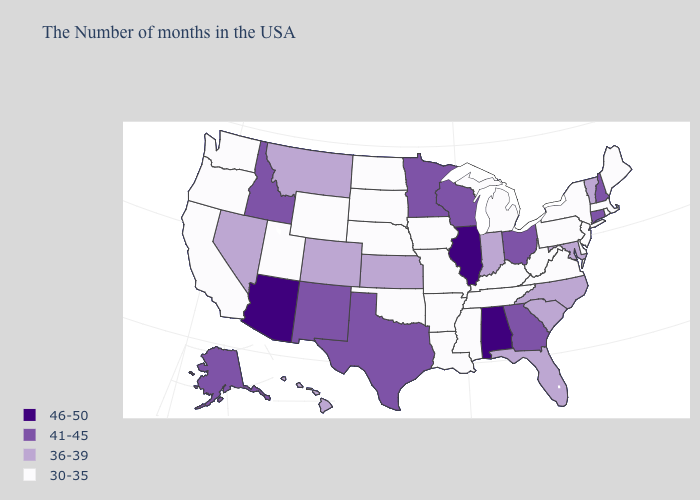How many symbols are there in the legend?
Answer briefly. 4. What is the value of Indiana?
Be succinct. 36-39. Name the states that have a value in the range 46-50?
Answer briefly. Alabama, Illinois, Arizona. Does Alabama have the highest value in the USA?
Concise answer only. Yes. What is the value of Missouri?
Give a very brief answer. 30-35. What is the value of Kentucky?
Answer briefly. 30-35. Name the states that have a value in the range 41-45?
Concise answer only. New Hampshire, Connecticut, Ohio, Georgia, Wisconsin, Minnesota, Texas, New Mexico, Idaho, Alaska. Name the states that have a value in the range 41-45?
Give a very brief answer. New Hampshire, Connecticut, Ohio, Georgia, Wisconsin, Minnesota, Texas, New Mexico, Idaho, Alaska. What is the value of Pennsylvania?
Keep it brief. 30-35. Which states have the lowest value in the USA?
Short answer required. Maine, Massachusetts, Rhode Island, New York, New Jersey, Delaware, Pennsylvania, Virginia, West Virginia, Michigan, Kentucky, Tennessee, Mississippi, Louisiana, Missouri, Arkansas, Iowa, Nebraska, Oklahoma, South Dakota, North Dakota, Wyoming, Utah, California, Washington, Oregon. Does North Dakota have the lowest value in the MidWest?
Quick response, please. Yes. Does the first symbol in the legend represent the smallest category?
Quick response, please. No. Is the legend a continuous bar?
Be succinct. No. Name the states that have a value in the range 30-35?
Give a very brief answer. Maine, Massachusetts, Rhode Island, New York, New Jersey, Delaware, Pennsylvania, Virginia, West Virginia, Michigan, Kentucky, Tennessee, Mississippi, Louisiana, Missouri, Arkansas, Iowa, Nebraska, Oklahoma, South Dakota, North Dakota, Wyoming, Utah, California, Washington, Oregon. Name the states that have a value in the range 36-39?
Concise answer only. Vermont, Maryland, North Carolina, South Carolina, Florida, Indiana, Kansas, Colorado, Montana, Nevada, Hawaii. 